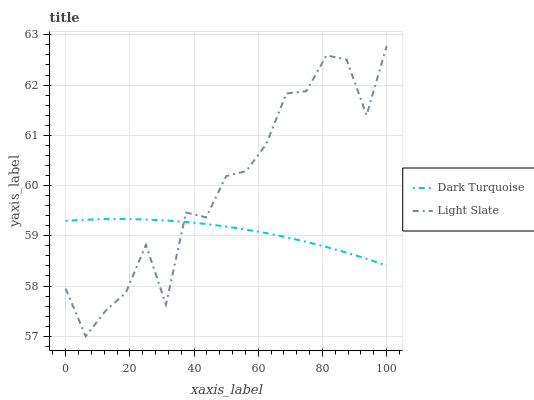Does Dark Turquoise have the minimum area under the curve?
Answer yes or no. Yes. Does Light Slate have the maximum area under the curve?
Answer yes or no. Yes. Does Dark Turquoise have the maximum area under the curve?
Answer yes or no. No. Is Dark Turquoise the smoothest?
Answer yes or no. Yes. Is Light Slate the roughest?
Answer yes or no. Yes. Is Dark Turquoise the roughest?
Answer yes or no. No. Does Light Slate have the lowest value?
Answer yes or no. Yes. Does Dark Turquoise have the lowest value?
Answer yes or no. No. Does Light Slate have the highest value?
Answer yes or no. Yes. Does Dark Turquoise have the highest value?
Answer yes or no. No. Does Dark Turquoise intersect Light Slate?
Answer yes or no. Yes. Is Dark Turquoise less than Light Slate?
Answer yes or no. No. Is Dark Turquoise greater than Light Slate?
Answer yes or no. No. 